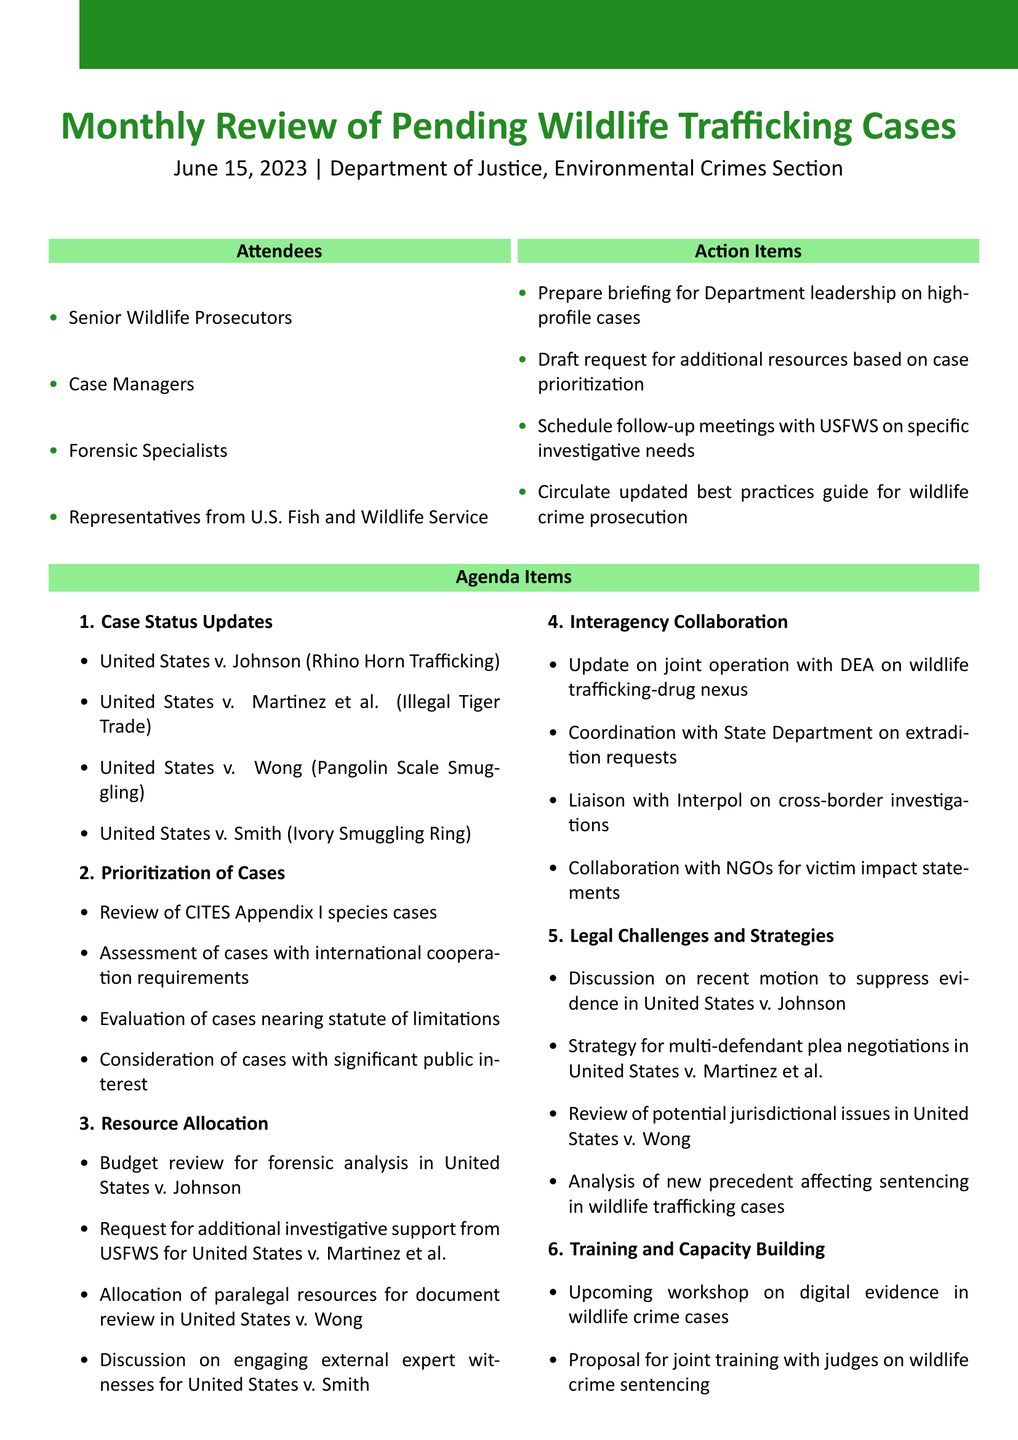What is the date of the meeting? The date of the meeting is explicitly stated in the document as June 15, 2023.
Answer: June 15, 2023 Where was the meeting held? The location of the meeting is mentioned in the document, indicating it took place at the Department of Justice, Environmental Crimes Section.
Answer: Department of Justice, Environmental Crimes Section Who is a participant listed as an attendee in the meeting? One of the attendees listed is "Senior Wildlife Prosecutors," which is found within the attendee section.
Answer: Senior Wildlife Prosecutors What is one specific case status updated in the meeting? The document specifies multiple cases, one of which is "United States v. Johnson (Rhino Horn Trafficking)."
Answer: United States v. Johnson (Rhino Horn Trafficking) What is a priority for resource allocation mentioned? The document notes the "Budget review for forensic analysis in United States v. Johnson" as a priority for resource allocation.
Answer: Budget review for forensic analysis in United States v. Johnson What type of training workshop is upcoming? The document states an "upcoming workshop on digital evidence in wildlife crime cases" is planned, which signifies the kind of training anticipated.
Answer: workshop on digital evidence in wildlife crime cases When is the next meeting scheduled? The next meeting date is provided in the document as July 13, 2023.
Answer: July 13, 2023 What is one legal challenge discussed? The document highlights the "Discussion on recent motion to suppress evidence in United States v. Johnson" as a legal challenge being addressed.
Answer: Discussion on recent motion to suppress evidence in United States v. Johnson 